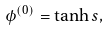Convert formula to latex. <formula><loc_0><loc_0><loc_500><loc_500>\phi ^ { ( 0 ) } = \tanh s ,</formula> 